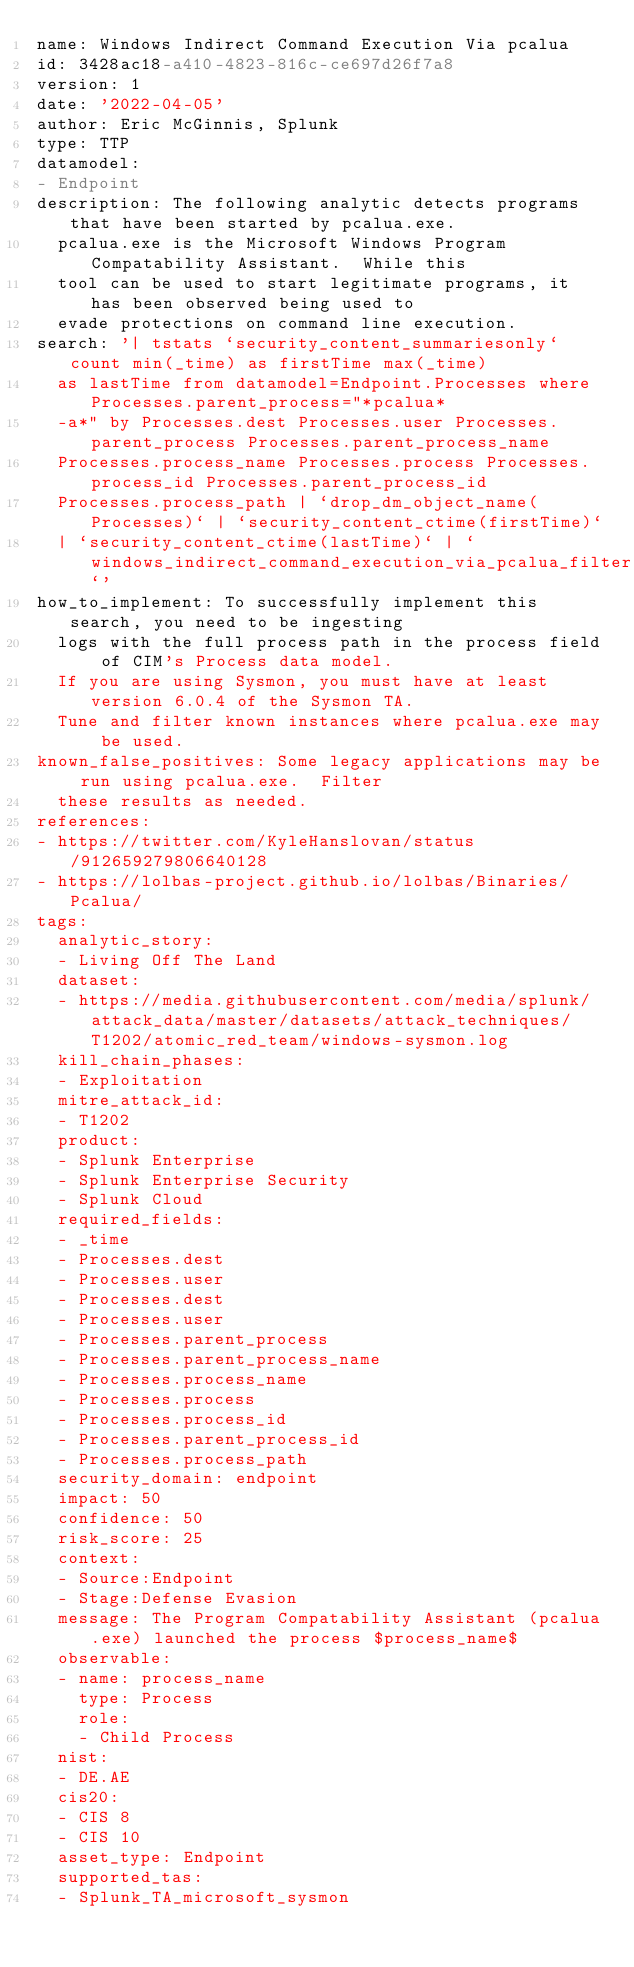<code> <loc_0><loc_0><loc_500><loc_500><_YAML_>name: Windows Indirect Command Execution Via pcalua
id: 3428ac18-a410-4823-816c-ce697d26f7a8
version: 1
date: '2022-04-05'
author: Eric McGinnis, Splunk
type: TTP
datamodel:
- Endpoint
description: The following analytic detects programs that have been started by pcalua.exe.
  pcalua.exe is the Microsoft Windows Program Compatability Assistant.  While this
  tool can be used to start legitimate programs, it has been observed being used to
  evade protections on command line execution.
search: '| tstats `security_content_summariesonly` count min(_time) as firstTime max(_time)
  as lastTime from datamodel=Endpoint.Processes where Processes.parent_process="*pcalua*
  -a*" by Processes.dest Processes.user Processes.parent_process Processes.parent_process_name
  Processes.process_name Processes.process Processes.process_id Processes.parent_process_id
  Processes.process_path | `drop_dm_object_name(Processes)` | `security_content_ctime(firstTime)`
  | `security_content_ctime(lastTime)` | `windows_indirect_command_execution_via_pcalua_filter`'
how_to_implement: To successfully implement this search, you need to be ingesting
  logs with the full process path in the process field of CIM's Process data model.
  If you are using Sysmon, you must have at least version 6.0.4 of the Sysmon TA.
  Tune and filter known instances where pcalua.exe may be used.
known_false_positives: Some legacy applications may be run using pcalua.exe.  Filter
  these results as needed.
references:
- https://twitter.com/KyleHanslovan/status/912659279806640128
- https://lolbas-project.github.io/lolbas/Binaries/Pcalua/
tags:
  analytic_story:
  - Living Off The Land
  dataset:
  - https://media.githubusercontent.com/media/splunk/attack_data/master/datasets/attack_techniques/T1202/atomic_red_team/windows-sysmon.log
  kill_chain_phases:
  - Exploitation
  mitre_attack_id:
  - T1202
  product:
  - Splunk Enterprise
  - Splunk Enterprise Security
  - Splunk Cloud
  required_fields:
  - _time
  - Processes.dest
  - Processes.user
  - Processes.dest
  - Processes.user
  - Processes.parent_process
  - Processes.parent_process_name
  - Processes.process_name
  - Processes.process
  - Processes.process_id
  - Processes.parent_process_id
  - Processes.process_path
  security_domain: endpoint
  impact: 50
  confidence: 50
  risk_score: 25
  context:
  - Source:Endpoint
  - Stage:Defense Evasion
  message: The Program Compatability Assistant (pcalua.exe) launched the process $process_name$
  observable:
  - name: process_name
    type: Process
    role:
    - Child Process
  nist:
  - DE.AE
  cis20:
  - CIS 8
  - CIS 10
  asset_type: Endpoint
  supported_tas:
  - Splunk_TA_microsoft_sysmon
</code> 